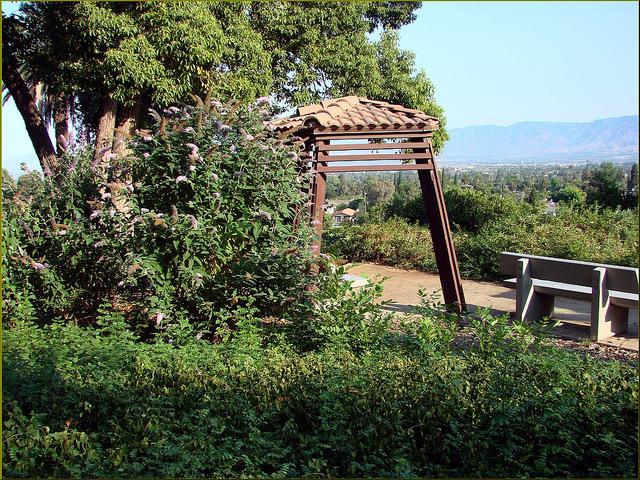Does this environment appear to be quiet?
Short answer required. Yes. Is there a tornado approaching?
Quick response, please. No. Are the benches made of logs?
Be succinct. No. Are there any humans visible in the photo?
Short answer required. No. 